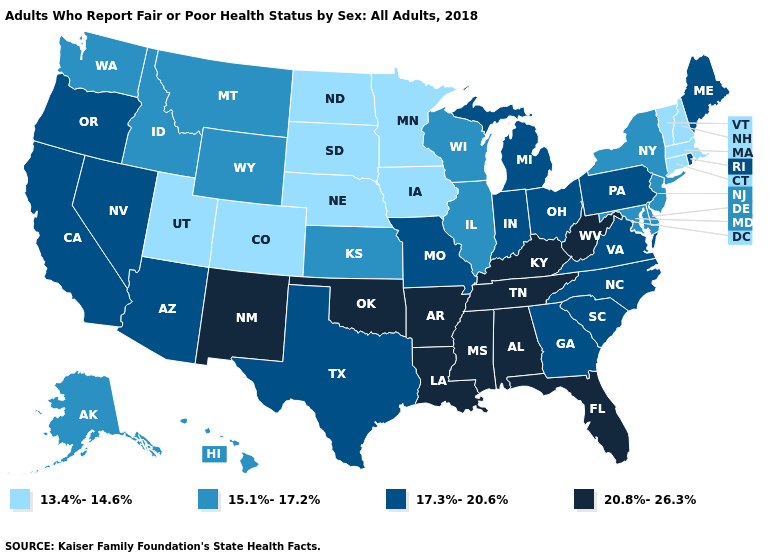How many symbols are there in the legend?
Write a very short answer. 4. Does South Carolina have the same value as Louisiana?
Short answer required. No. Does Rhode Island have the lowest value in the USA?
Be succinct. No. What is the highest value in the USA?
Answer briefly. 20.8%-26.3%. Among the states that border West Virginia , does Maryland have the lowest value?
Short answer required. Yes. Does New Mexico have the highest value in the West?
Answer briefly. Yes. What is the value of Michigan?
Short answer required. 17.3%-20.6%. Among the states that border Alabama , which have the lowest value?
Write a very short answer. Georgia. What is the value of Oregon?
Answer briefly. 17.3%-20.6%. Does Arkansas have the highest value in the USA?
Quick response, please. Yes. Does New Mexico have the highest value in the West?
Short answer required. Yes. What is the value of Georgia?
Be succinct. 17.3%-20.6%. Does Rhode Island have the highest value in the Northeast?
Be succinct. Yes. Does Tennessee have the highest value in the USA?
Give a very brief answer. Yes. Does South Dakota have the same value as Florida?
Give a very brief answer. No. 